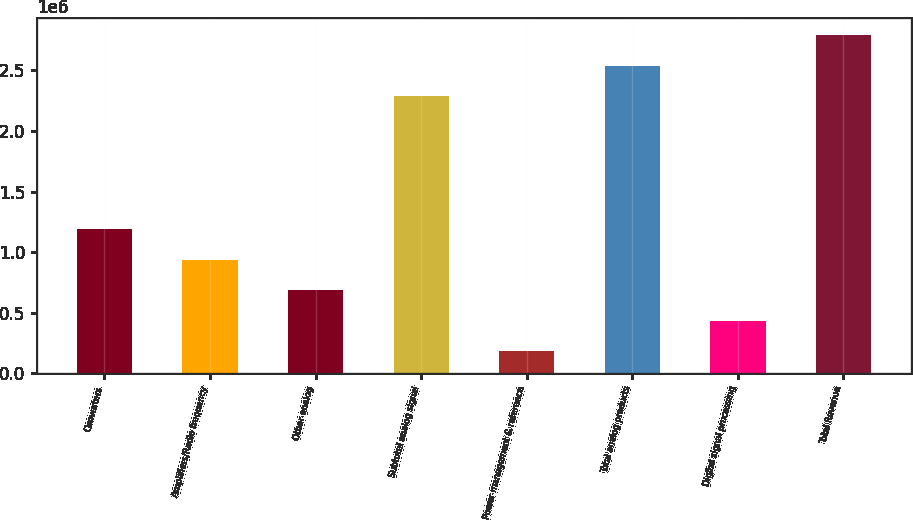Convert chart. <chart><loc_0><loc_0><loc_500><loc_500><bar_chart><fcel>Converters<fcel>Amplifiers/Radio frequency<fcel>Other analog<fcel>Subtotal analog signal<fcel>Power management & reference<fcel>Total analog products<fcel>Digital signal processing<fcel>Total Revenue<nl><fcel>1.19206e+06<fcel>937836<fcel>685936<fcel>2.28713e+06<fcel>182134<fcel>2.53903e+06<fcel>434035<fcel>2.79093e+06<nl></chart> 